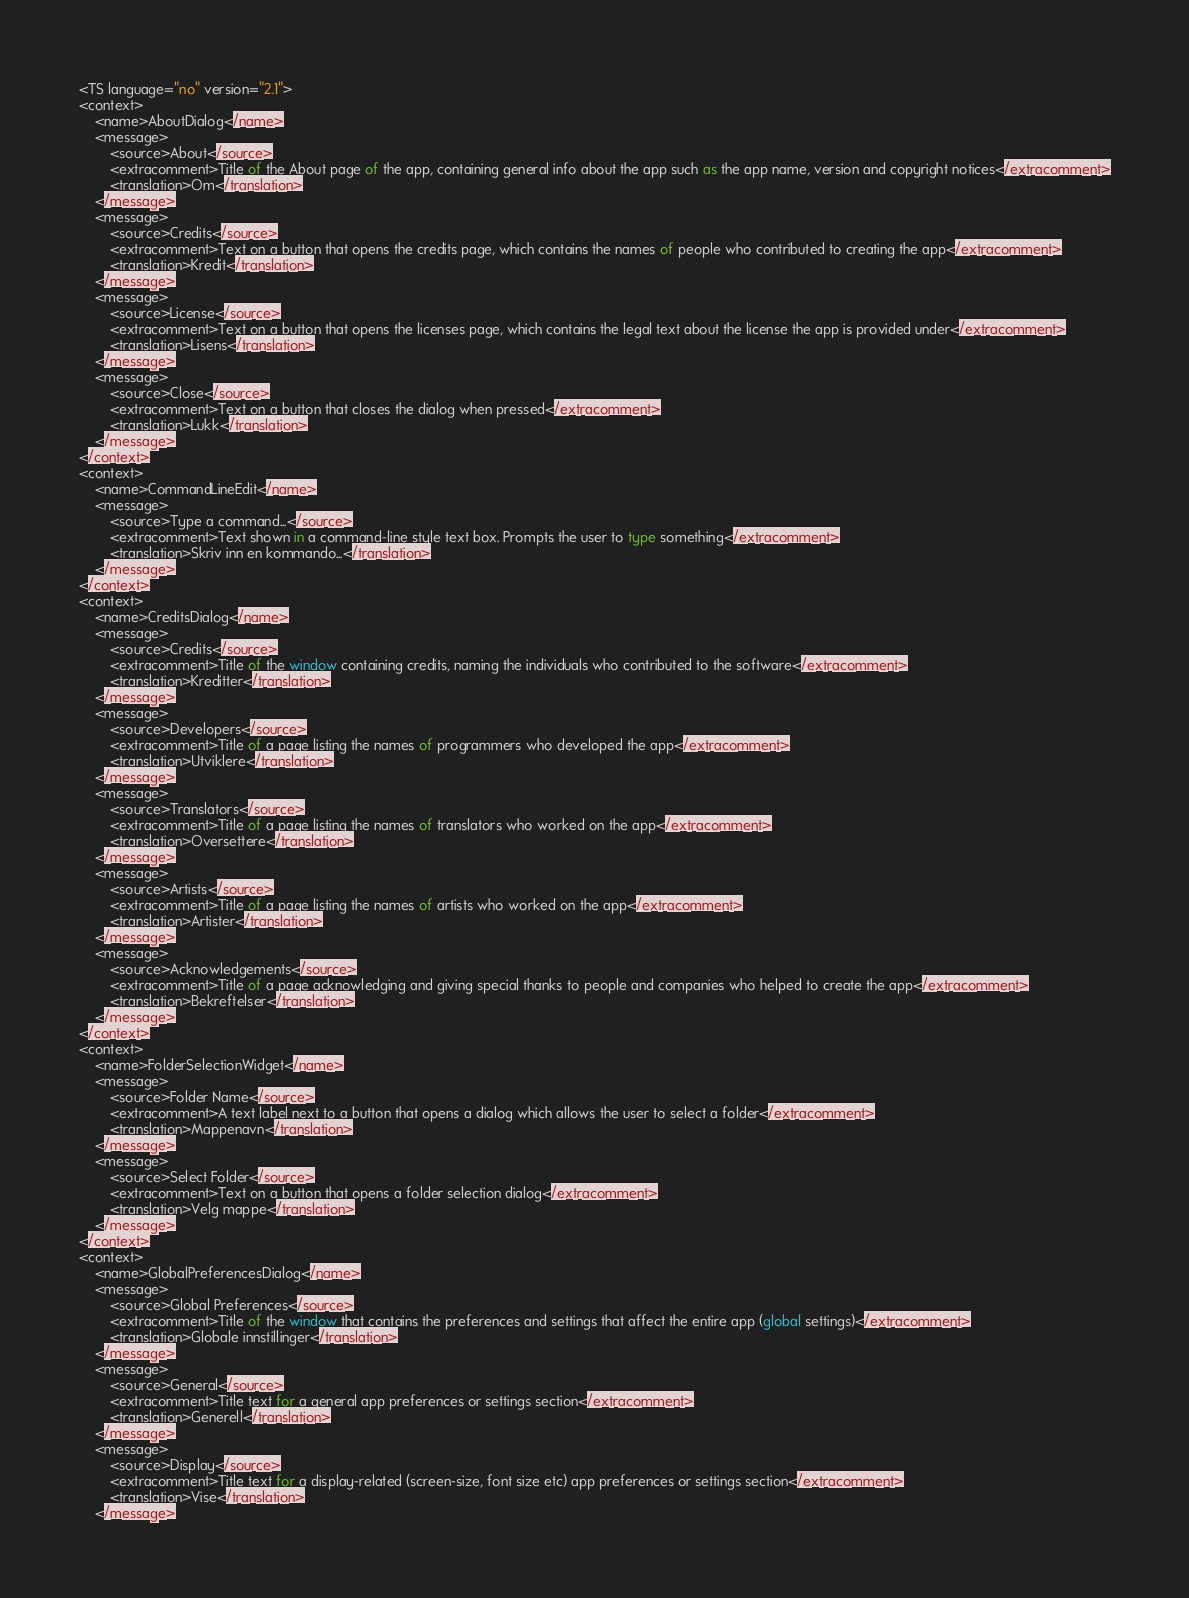<code> <loc_0><loc_0><loc_500><loc_500><_TypeScript_><TS language="no" version="2.1">
<context>
    <name>AboutDialog</name>
    <message>
        <source>About</source>
        <extracomment>Title of the About page of the app, containing general info about the app such as the app name, version and copyright notices</extracomment>
        <translation>Om</translation>
    </message>
    <message>
        <source>Credits</source>
        <extracomment>Text on a button that opens the credits page, which contains the names of people who contributed to creating the app</extracomment>
        <translation>Kredit</translation>
    </message>
    <message>
        <source>License</source>
        <extracomment>Text on a button that opens the licenses page, which contains the legal text about the license the app is provided under</extracomment>
        <translation>Lisens</translation>
    </message>
    <message>
        <source>Close</source>
        <extracomment>Text on a button that closes the dialog when pressed</extracomment>
        <translation>Lukk</translation>
    </message>
</context>
<context>
    <name>CommandLineEdit</name>
    <message>
        <source>Type a command...</source>
        <extracomment>Text shown in a command-line style text box. Prompts the user to type something</extracomment>
        <translation>Skriv inn en kommando...</translation>
    </message>
</context>
<context>
    <name>CreditsDialog</name>
    <message>
        <source>Credits</source>
        <extracomment>Title of the window containing credits, naming the individuals who contributed to the software</extracomment>
        <translation>Kreditter</translation>
    </message>
    <message>
        <source>Developers</source>
        <extracomment>Title of a page listing the names of programmers who developed the app</extracomment>
        <translation>Utviklere</translation>
    </message>
    <message>
        <source>Translators</source>
        <extracomment>Title of a page listing the names of translators who worked on the app</extracomment>
        <translation>Oversettere</translation>
    </message>
    <message>
        <source>Artists</source>
        <extracomment>Title of a page listing the names of artists who worked on the app</extracomment>
        <translation>Artister</translation>
    </message>
    <message>
        <source>Acknowledgements</source>
        <extracomment>Title of a page acknowledging and giving special thanks to people and companies who helped to create the app</extracomment>
        <translation>Bekreftelser</translation>
    </message>
</context>
<context>
    <name>FolderSelectionWidget</name>
    <message>
        <source>Folder Name</source>
        <extracomment>A text label next to a button that opens a dialog which allows the user to select a folder</extracomment>
        <translation>Mappenavn</translation>
    </message>
    <message>
        <source>Select Folder</source>
        <extracomment>Text on a button that opens a folder selection dialog</extracomment>
        <translation>Velg mappe</translation>
    </message>
</context>
<context>
    <name>GlobalPreferencesDialog</name>
    <message>
        <source>Global Preferences</source>
        <extracomment>Title of the window that contains the preferences and settings that affect the entire app (global settings)</extracomment>
        <translation>Globale innstillinger</translation>
    </message>
    <message>
        <source>General</source>
        <extracomment>Title text for a general app preferences or settings section</extracomment>
        <translation>Generell</translation>
    </message>
    <message>
        <source>Display</source>
        <extracomment>Title text for a display-related (screen-size, font size etc) app preferences or settings section</extracomment>
        <translation>Vise</translation>
    </message></code> 